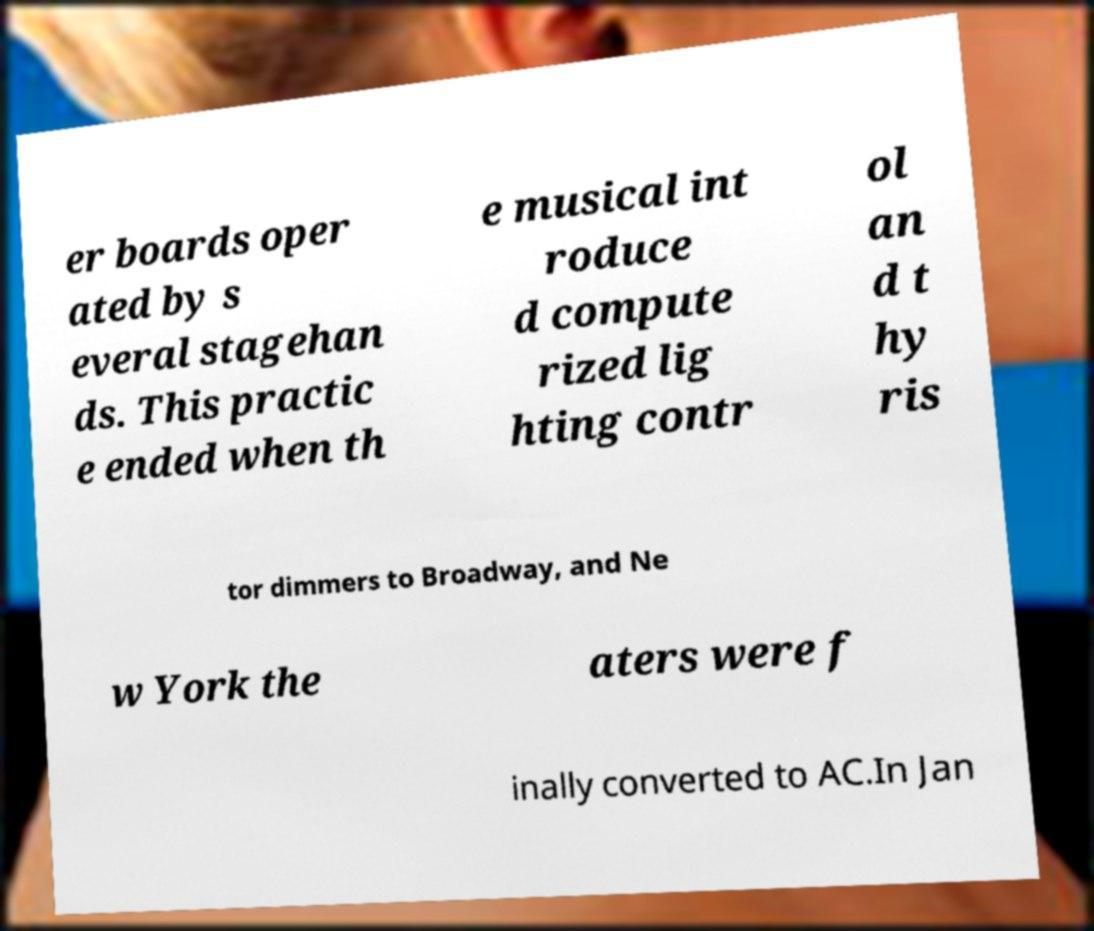For documentation purposes, I need the text within this image transcribed. Could you provide that? er boards oper ated by s everal stagehan ds. This practic e ended when th e musical int roduce d compute rized lig hting contr ol an d t hy ris tor dimmers to Broadway, and Ne w York the aters were f inally converted to AC.In Jan 